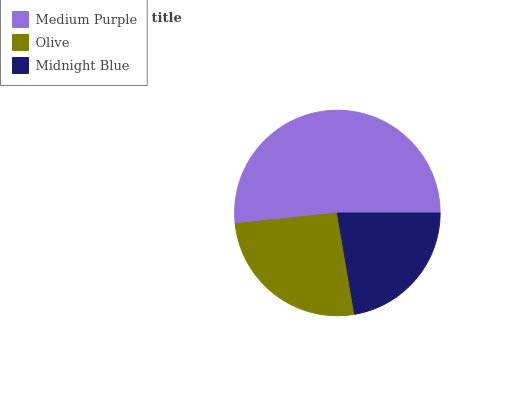Is Midnight Blue the minimum?
Answer yes or no. Yes. Is Medium Purple the maximum?
Answer yes or no. Yes. Is Olive the minimum?
Answer yes or no. No. Is Olive the maximum?
Answer yes or no. No. Is Medium Purple greater than Olive?
Answer yes or no. Yes. Is Olive less than Medium Purple?
Answer yes or no. Yes. Is Olive greater than Medium Purple?
Answer yes or no. No. Is Medium Purple less than Olive?
Answer yes or no. No. Is Olive the high median?
Answer yes or no. Yes. Is Olive the low median?
Answer yes or no. Yes. Is Midnight Blue the high median?
Answer yes or no. No. Is Medium Purple the low median?
Answer yes or no. No. 